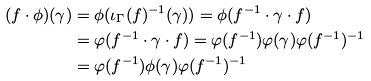<formula> <loc_0><loc_0><loc_500><loc_500>( f \cdot \phi ) ( \gamma ) & = \phi ( \iota _ { \Gamma } ( f ) ^ { - 1 } ( \gamma ) ) = \phi ( f ^ { - 1 } \cdot \gamma \cdot f ) \\ & = \varphi ( f ^ { - 1 } \cdot \gamma \cdot f ) = \varphi ( f ^ { - 1 } ) \varphi ( \gamma ) \varphi ( f ^ { - 1 } ) ^ { - 1 } \\ & = \varphi ( f ^ { - 1 } ) \phi ( \gamma ) \varphi ( f ^ { - 1 } ) ^ { - 1 }</formula> 